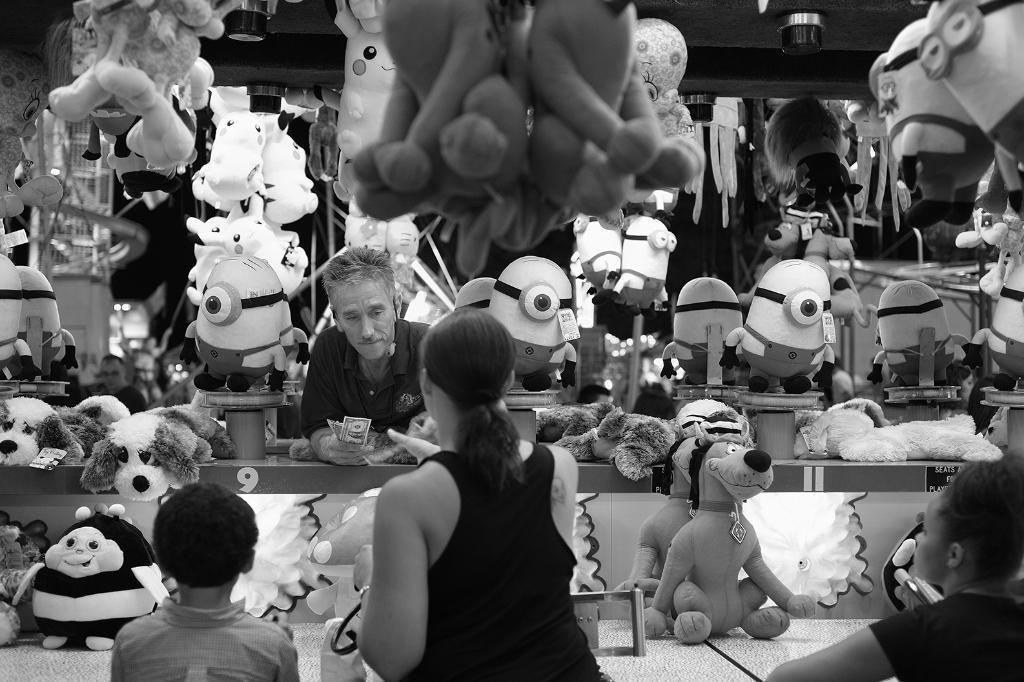Can you describe this image briefly? In this picture we can see persons and a group of toys. 